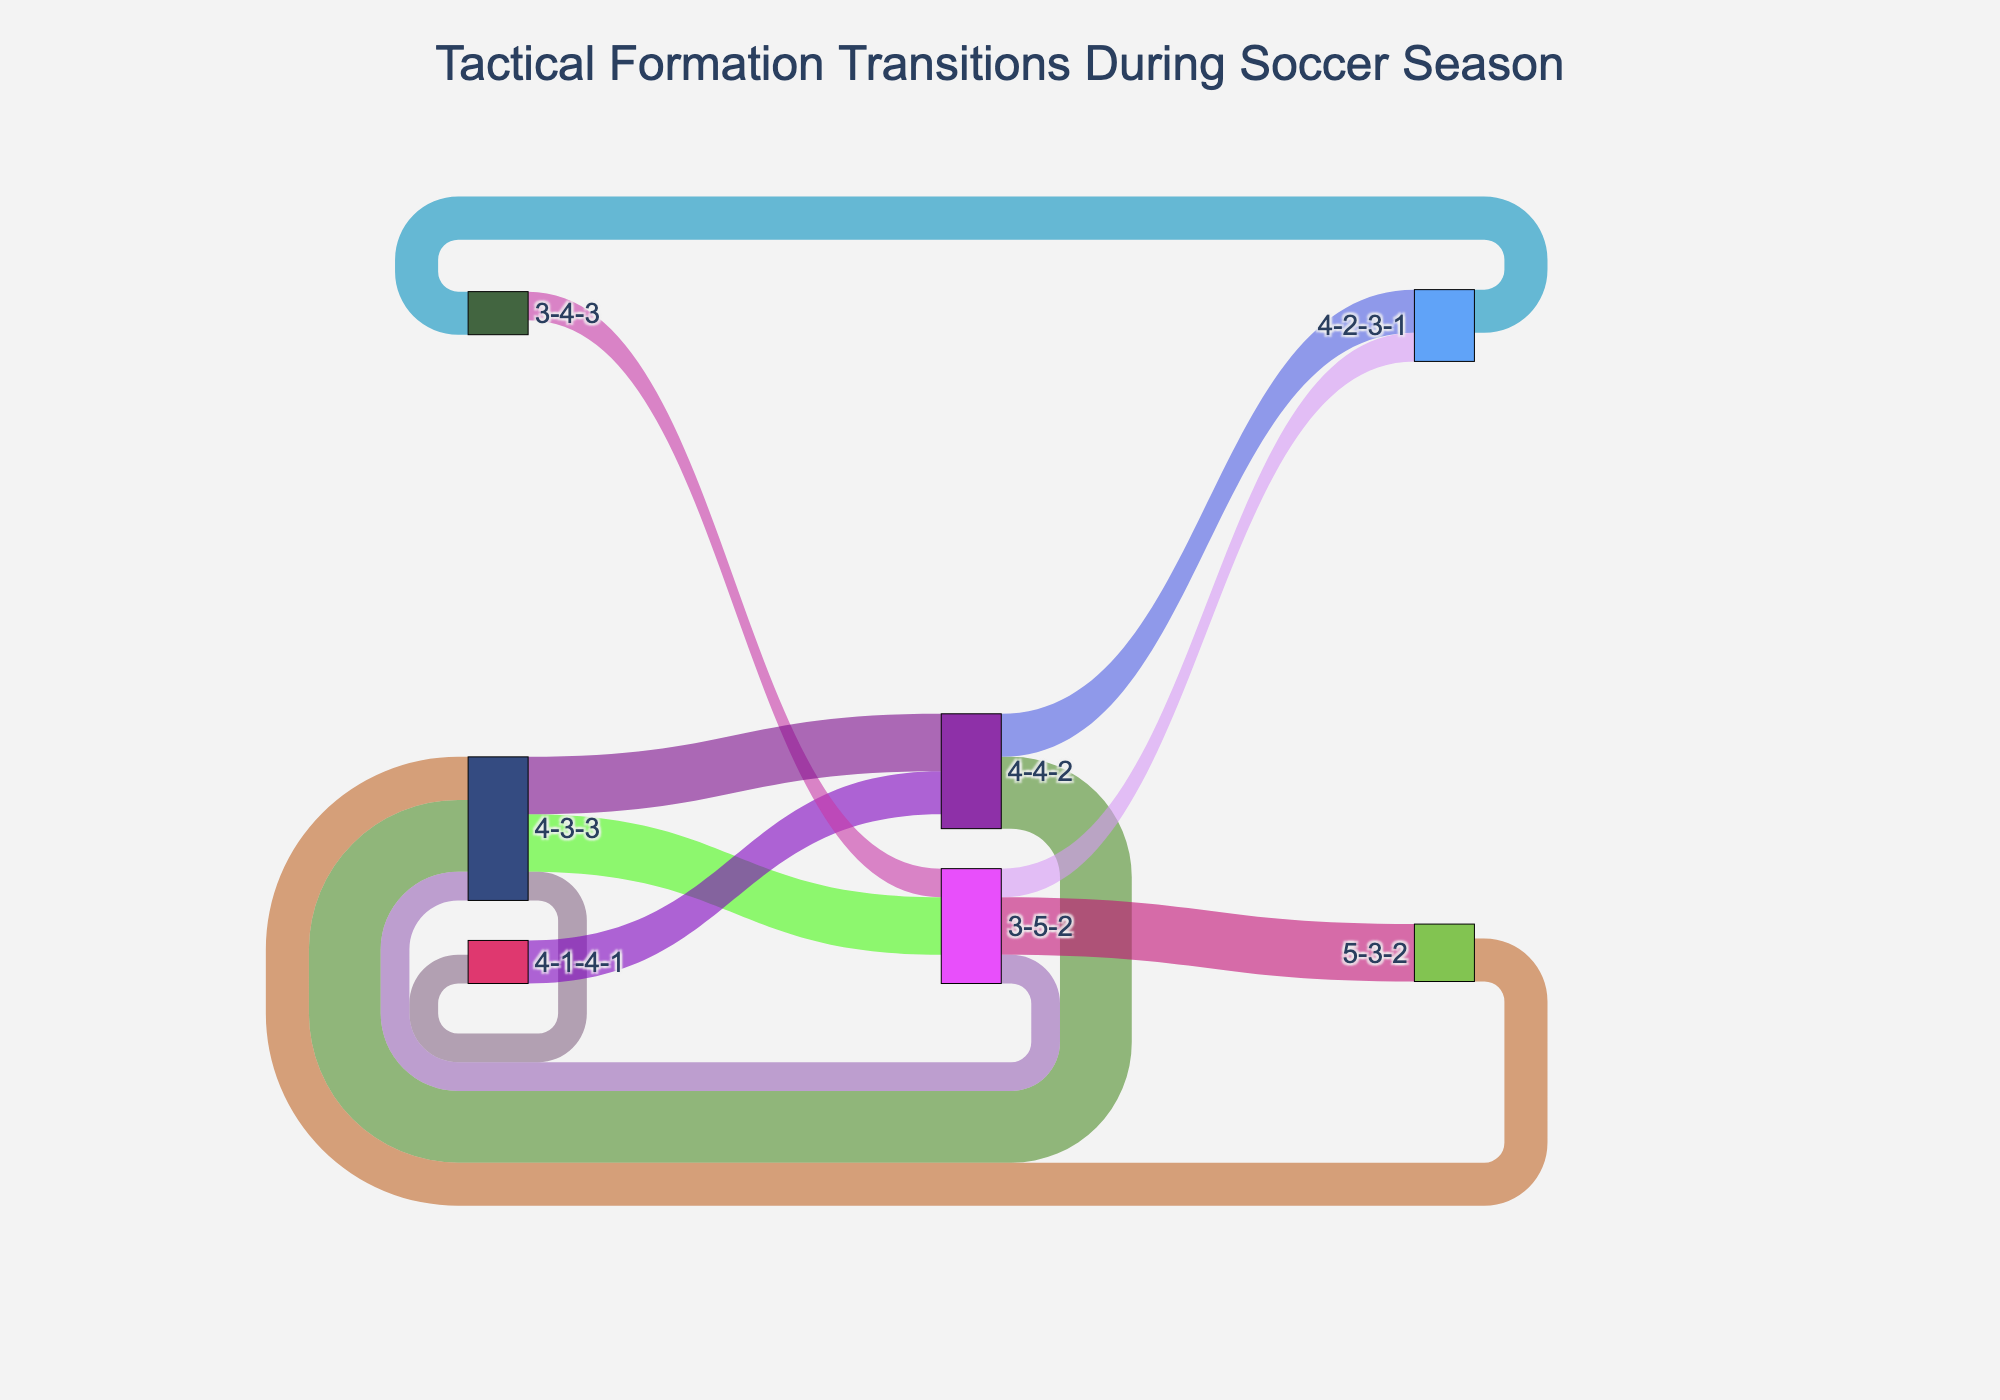What's the title of the figure? The title of the figure is displayed at the top center. It reads "Tactical Formation Transitions During Soccer Season".
Answer: Tactical Formation Transitions During Soccer Season What color is most frequently used for the transition links? Each transition link has a unique color, so there is no color that is used more often than others.
Answer: No dominant color How many different formations were used as source points? To find how many different formations were used as source points, count the unique values in the 'source' column of the provided data.
Answer: 6 How many times did the 4-4-2 formation transition to other formations? By looking at the data, the 4-4-2 formation transitions to 4-3-3 five times and to 4-2-3-1 three times. Summing these transitions gives 5 + 3 = 8.
Answer: 8 Which formation had the most transitions away from it as a target formation? By counting how many times each formation appears in the 'target' column, we see that 4-3-3 appears the most, being the target formation five times.
Answer: 4-3-3 What is the total number of formation transitions depicted in the diagram? By summing up all the 'value' entries in the data, the total number of transitions is 5 + 3 + 4 + 2 + 3 + 4 + 2 + 3 + 2 + 3 + 4 + 2 = 37.
Answer: 37 How frequently did the 3-5-2 formation transition to another formation? From the data, the 3-5-2 formation transitioned to 5-3-2 four times, to 4-3-3 two times, and to 4-2-3-1 two times. Adding these up, 4 + 2 + 2 = 8.
Answer: 8 What is the total number of transitions ending in formation 4-3-3? By summing up all the transition values ending in 4-3-3, which are: 5 (from 4-4-2), 2 (from 3-5-2), and 3 (from 5-3-2), we get 5 + 2 + 3 = 10.
Answer: 10 What's the most common source formation for the 4-3-3 formation? By looking at the data, the most common source formation for 4-3-3 is 4-4-2 with a count of 5.
Answer: 4-4-2 Which formation did the 4-1-4-1 transition into most frequently? According to the data, the 4-1-4-1 formation transitioned into 4-4-2 three times.
Answer: 4-4-2 